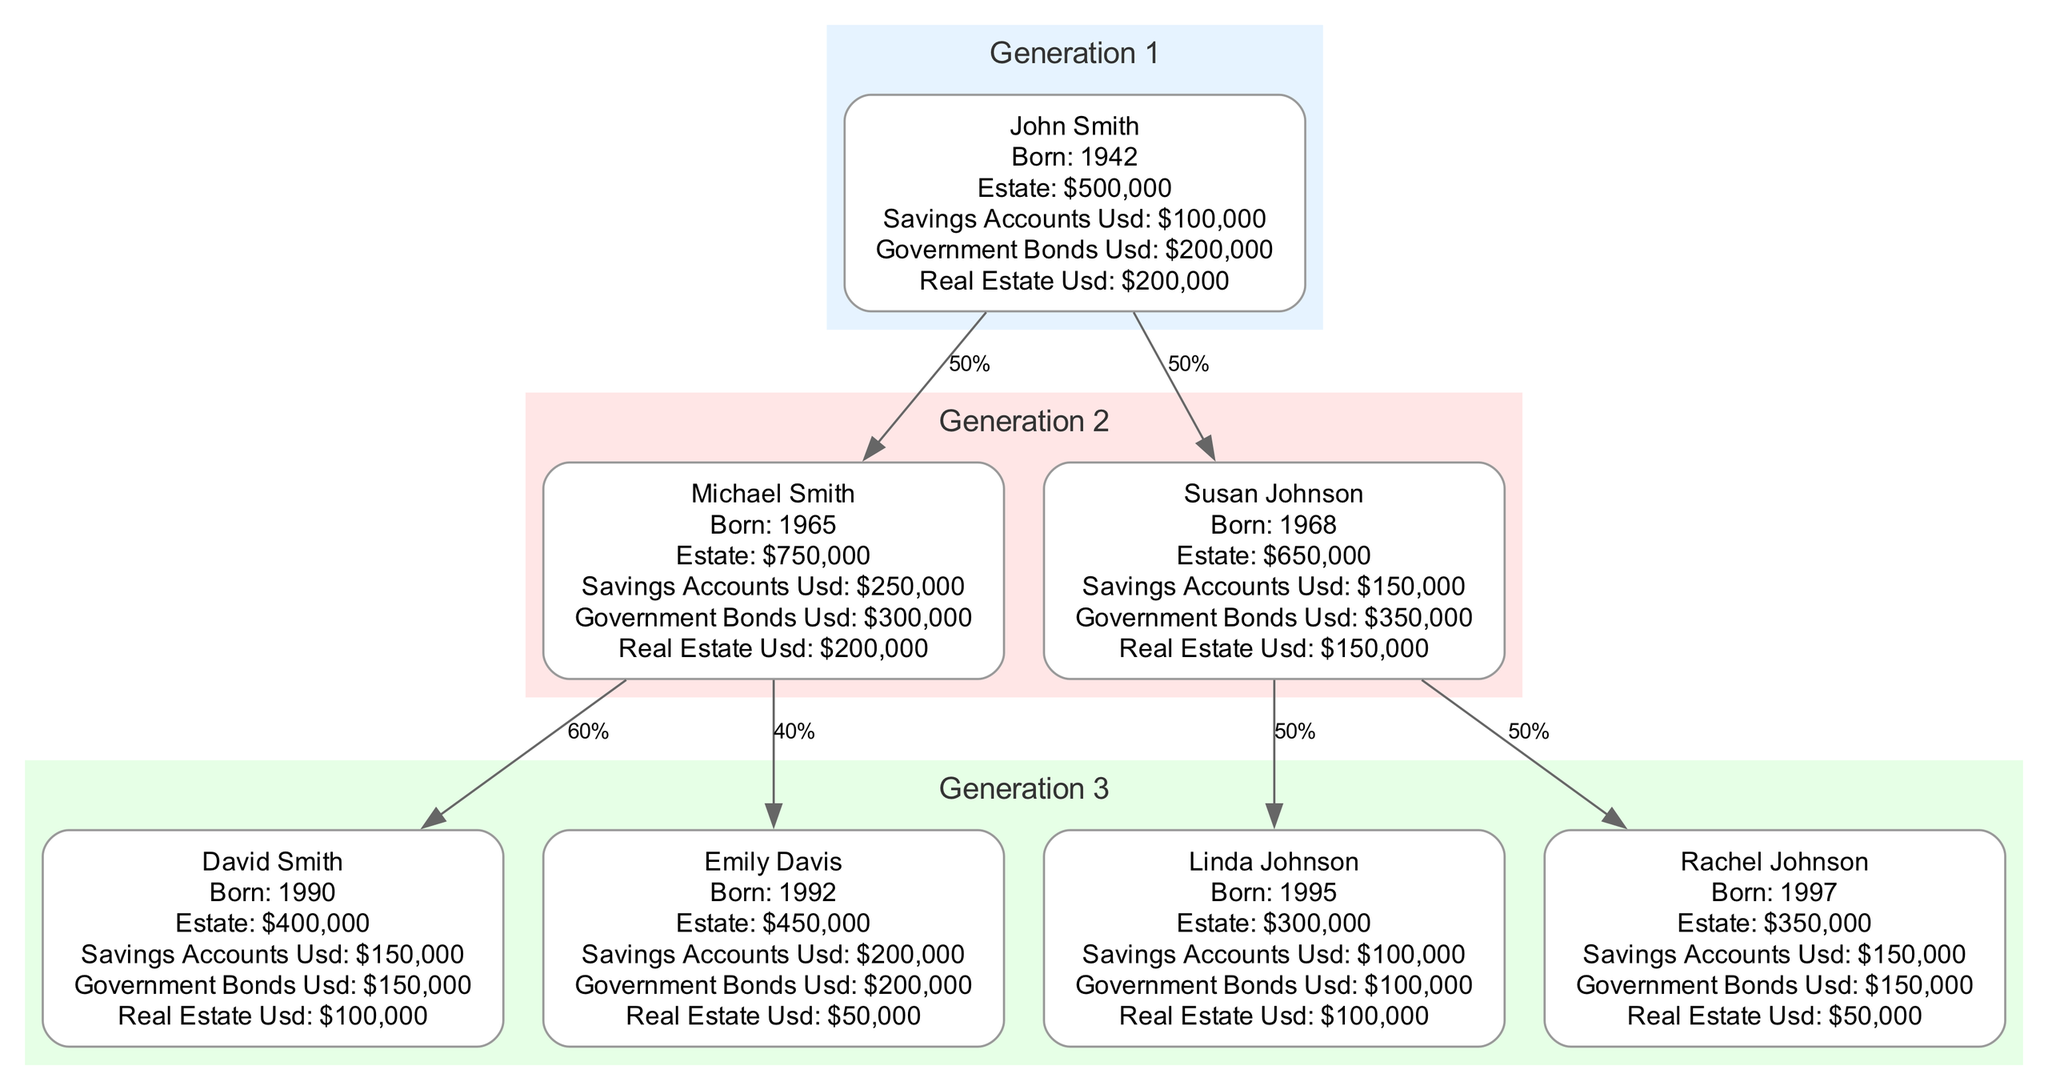What was the estate value of John Smith? John Smith's estate value is presented in the first generation box. It states the estate value is $500,000.
Answer: $500,000 How many children did Michael Smith have? Michael Smith has two heirs listed in the diagram: David Smith and Emily Davis. This is discerned from the heirs section under Michael's node.
Answer: 2 Who inherits from Susan Johnson? Susan Johnson has two daughters listed as heirs: Linda Johnson and Rachel Johnson, as indicated in her heirs section.
Answer: Linda Johnson and Rachel Johnson What percentage of his estate does David Smith inherit? David Smith does not have any heirs, which means he does not inherit anything from anyone. This is evident from the absence of heirs listed under David's node.
Answer: 0% Which individual has the highest estate value? The estate values are $500,000 for John Smith, $750,000 for Michael Smith, $650,000 for Susan Johnson, $400,000 for David Smith, $450,000 for Emily Davis, $300,000 for Linda Johnson, and $350,000 for Rachel Johnson. Michael Smith has the highest value of $750,000.
Answer: $750,000 What is the total estate value of the heirs of John Smith? Heirs Michael Smith and Susan Johnson's total estates are calculated by summing their respective estate values: $750,000 + $650,000 = $1,400,000. The connection is traced from John's heirs to their corresponding estates.
Answer: $1,400,000 How many generations are represented in the diagram? The diagram is structured with three groups: Generation 1, Generation 2, and Generation 3. Each group is distinctly labeled, indicating three generations in total.
Answer: 3 Which generation does Rachel Johnson belong to? Rachel Johnson is listed under the third generation in the diagram, confirmed by the organization of individuals into distinct generation clusters.
Answer: Generation 3 What type of conservative investment does Emily Davis have the most of? Emily Davis has $200,000 in government bonds, which is more than her other types of investments: $200,000 in government bonds, $200,000 in savings accounts, and $50,000 in real estate. This can be derived by comparing the amounts in her conservative investments section.
Answer: Government bonds 